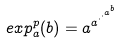<formula> <loc_0><loc_0><loc_500><loc_500>e x p _ { a } ^ { p } ( b ) = a ^ { a ^ { \cdot ^ { \cdot ^ { a ^ { b } } } } }</formula> 